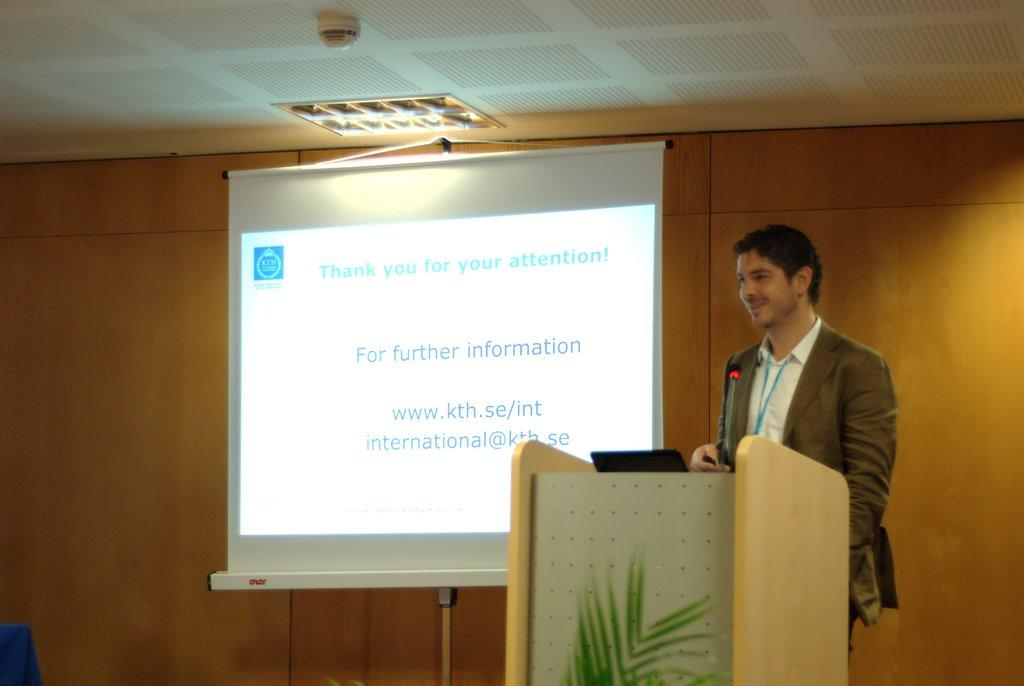<image>
Provide a brief description of the given image. A man speaks near a screen that says thank you for your attention on the top. 